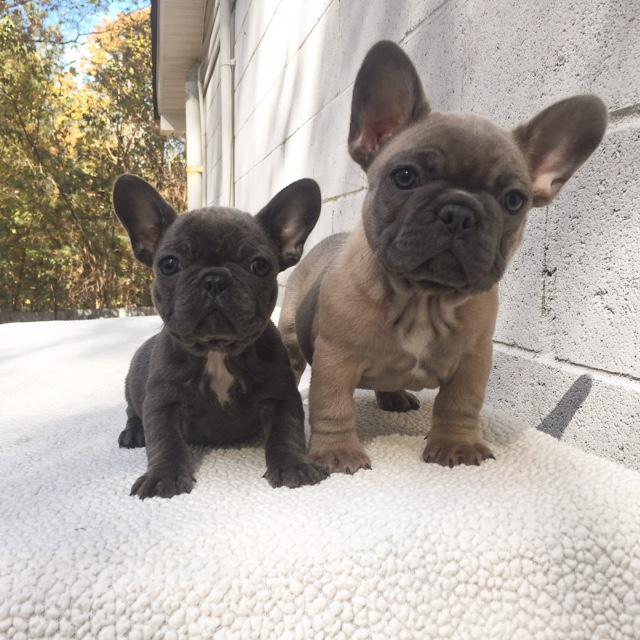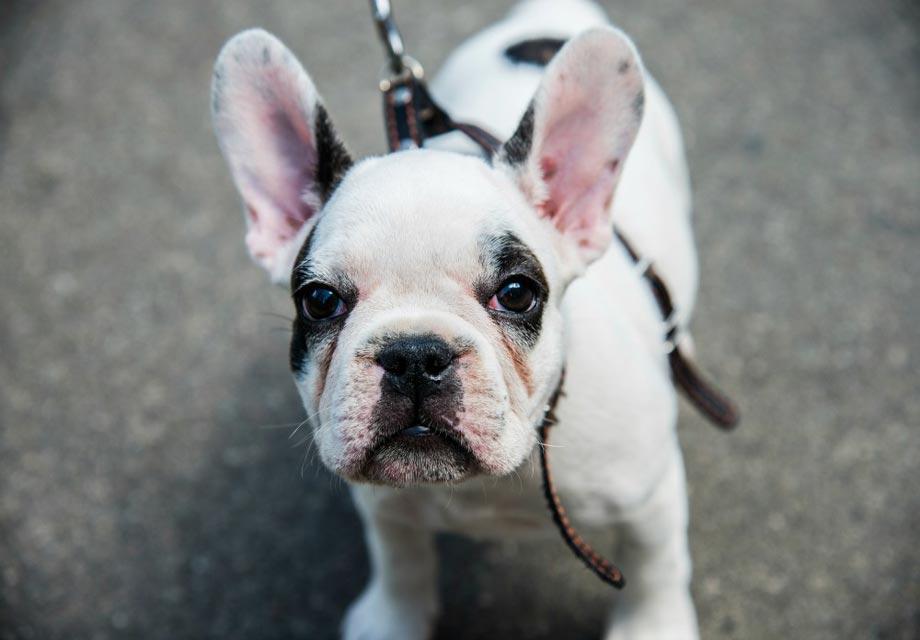The first image is the image on the left, the second image is the image on the right. For the images displayed, is the sentence "One of the images shows exactly two dogs." factually correct? Answer yes or no. Yes. The first image is the image on the left, the second image is the image on the right. For the images displayed, is the sentence "An image shows exactly two real puppies." factually correct? Answer yes or no. Yes. 